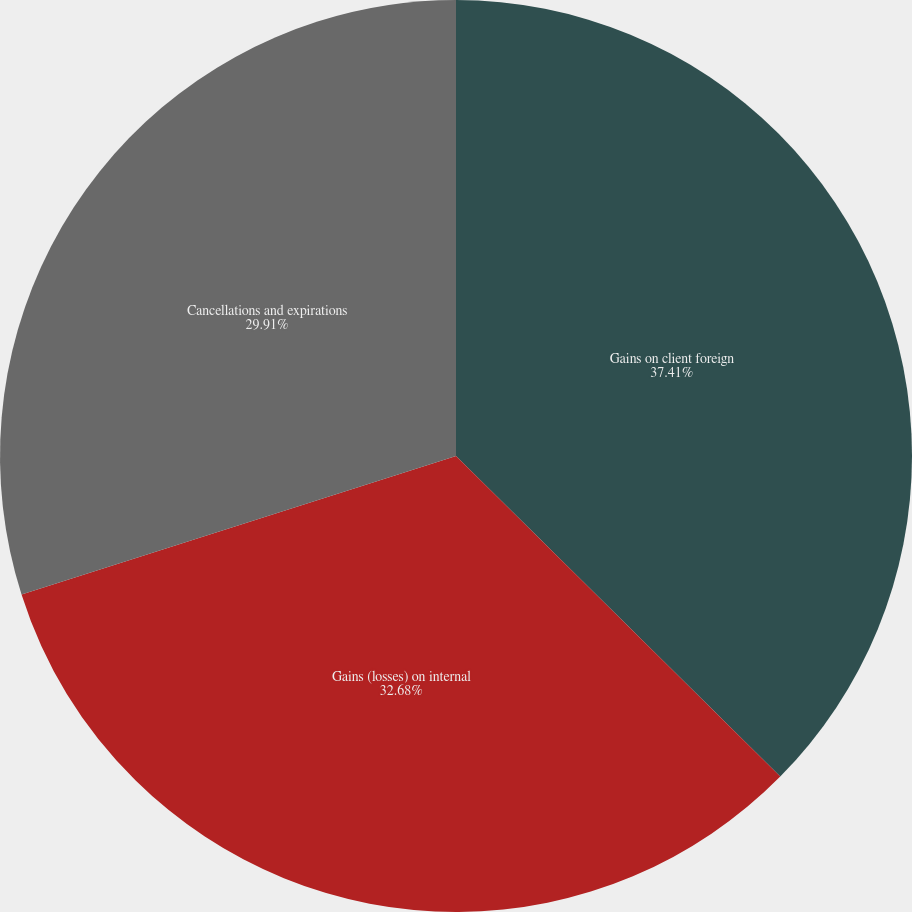<chart> <loc_0><loc_0><loc_500><loc_500><pie_chart><fcel>Gains on client foreign<fcel>Gains (losses) on internal<fcel>Cancellations and expirations<nl><fcel>37.41%<fcel>32.68%<fcel>29.91%<nl></chart> 